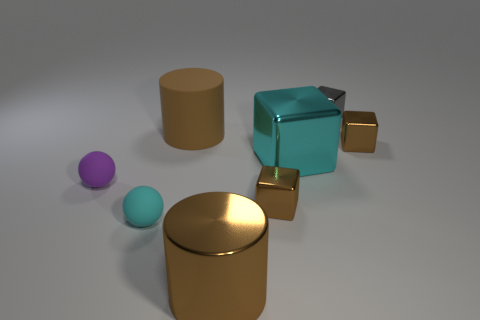How many other objects are the same color as the large block?
Your answer should be compact. 1. What number of objects are big purple rubber cylinders or brown metal cylinders?
Your answer should be compact. 1. What number of objects are green metal balls or tiny things to the left of the large cyan metallic block?
Offer a very short reply. 3. Do the tiny cyan object and the gray block have the same material?
Give a very brief answer. No. How many other objects are there of the same material as the tiny purple sphere?
Ensure brevity in your answer.  2. Are there more yellow objects than brown metallic cylinders?
Ensure brevity in your answer.  No. There is a small metallic thing that is behind the brown rubber cylinder; is it the same shape as the brown rubber thing?
Give a very brief answer. No. Is the number of large cylinders less than the number of large metal blocks?
Provide a short and direct response. No. There is a cyan thing that is the same size as the purple object; what is its material?
Make the answer very short. Rubber. Does the big shiny cylinder have the same color as the tiny object right of the tiny gray shiny block?
Your answer should be compact. Yes. 